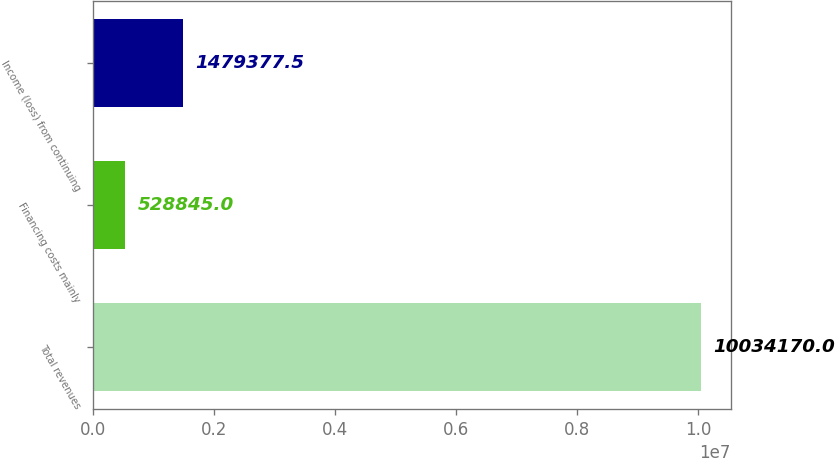Convert chart. <chart><loc_0><loc_0><loc_500><loc_500><bar_chart><fcel>Total revenues<fcel>Financing costs mainly<fcel>Income (loss) from continuing<nl><fcel>1.00342e+07<fcel>528845<fcel>1.47938e+06<nl></chart> 